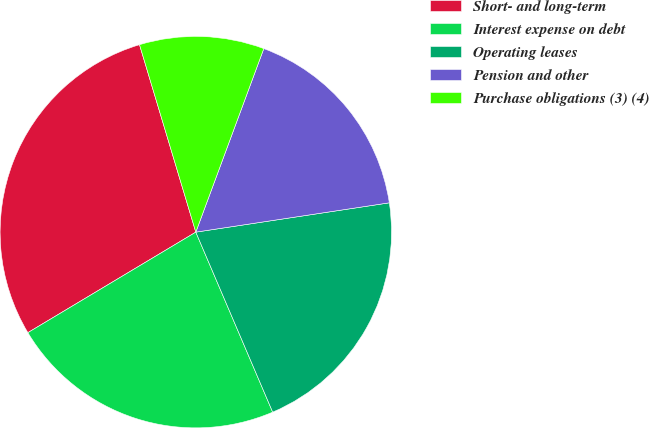<chart> <loc_0><loc_0><loc_500><loc_500><pie_chart><fcel>Short- and long-term<fcel>Interest expense on debt<fcel>Operating leases<fcel>Pension and other<fcel>Purchase obligations (3) (4)<nl><fcel>28.94%<fcel>22.84%<fcel>20.97%<fcel>16.96%<fcel>10.29%<nl></chart> 